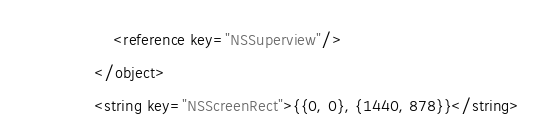Convert code to text. <code><loc_0><loc_0><loc_500><loc_500><_XML_>					<reference key="NSSuperview"/>
				</object>
				<string key="NSScreenRect">{{0, 0}, {1440, 878}}</string></code> 